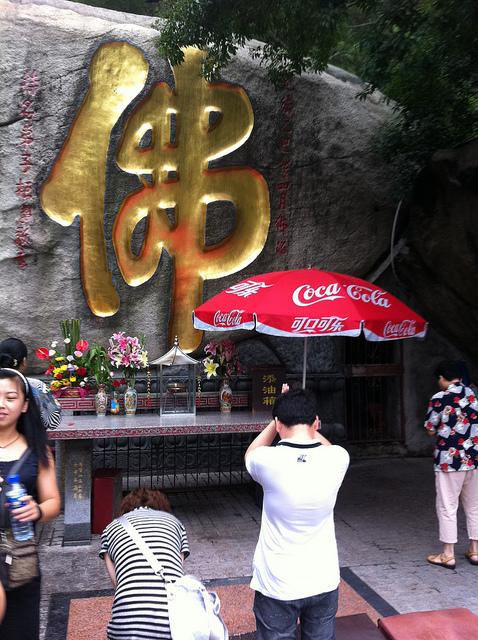What Pantone is Coca Cola red?

Choices:
A) pms484
B) pms492
C) pms112
D) pms452 pms484 